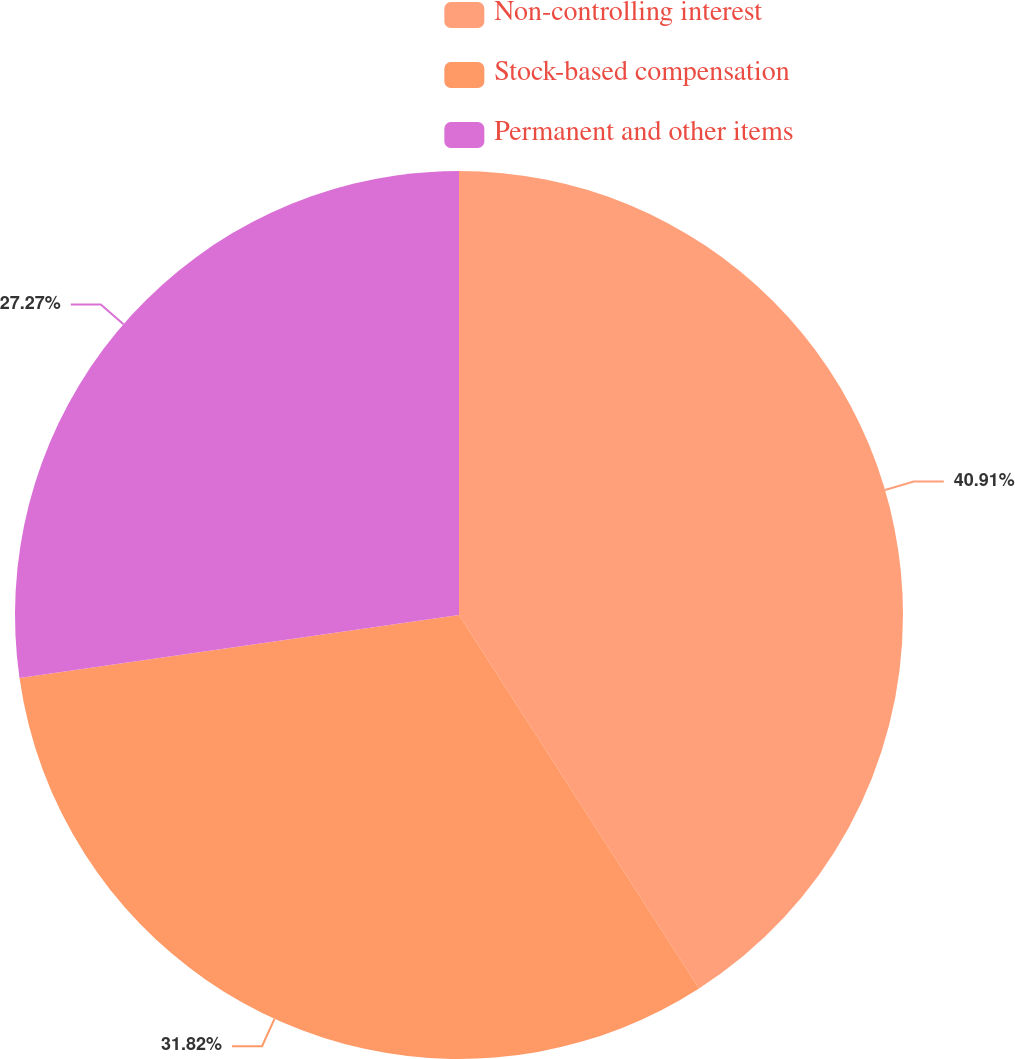<chart> <loc_0><loc_0><loc_500><loc_500><pie_chart><fcel>Non-controlling interest<fcel>Stock-based compensation<fcel>Permanent and other items<nl><fcel>40.91%<fcel>31.82%<fcel>27.27%<nl></chart> 